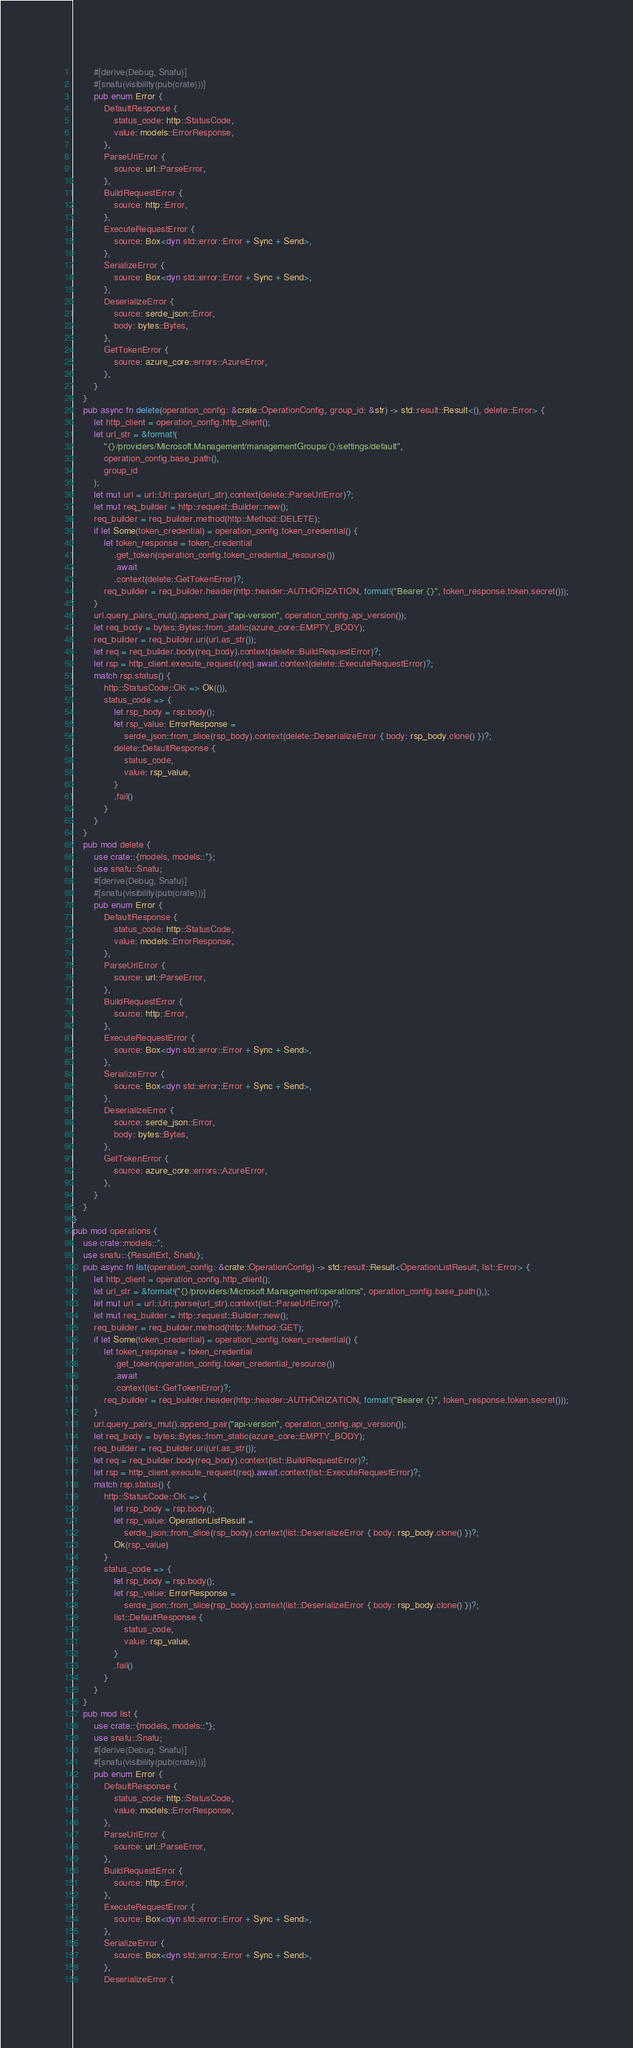<code> <loc_0><loc_0><loc_500><loc_500><_Rust_>        #[derive(Debug, Snafu)]
        #[snafu(visibility(pub(crate)))]
        pub enum Error {
            DefaultResponse {
                status_code: http::StatusCode,
                value: models::ErrorResponse,
            },
            ParseUrlError {
                source: url::ParseError,
            },
            BuildRequestError {
                source: http::Error,
            },
            ExecuteRequestError {
                source: Box<dyn std::error::Error + Sync + Send>,
            },
            SerializeError {
                source: Box<dyn std::error::Error + Sync + Send>,
            },
            DeserializeError {
                source: serde_json::Error,
                body: bytes::Bytes,
            },
            GetTokenError {
                source: azure_core::errors::AzureError,
            },
        }
    }
    pub async fn delete(operation_config: &crate::OperationConfig, group_id: &str) -> std::result::Result<(), delete::Error> {
        let http_client = operation_config.http_client();
        let url_str = &format!(
            "{}/providers/Microsoft.Management/managementGroups/{}/settings/default",
            operation_config.base_path(),
            group_id
        );
        let mut url = url::Url::parse(url_str).context(delete::ParseUrlError)?;
        let mut req_builder = http::request::Builder::new();
        req_builder = req_builder.method(http::Method::DELETE);
        if let Some(token_credential) = operation_config.token_credential() {
            let token_response = token_credential
                .get_token(operation_config.token_credential_resource())
                .await
                .context(delete::GetTokenError)?;
            req_builder = req_builder.header(http::header::AUTHORIZATION, format!("Bearer {}", token_response.token.secret()));
        }
        url.query_pairs_mut().append_pair("api-version", operation_config.api_version());
        let req_body = bytes::Bytes::from_static(azure_core::EMPTY_BODY);
        req_builder = req_builder.uri(url.as_str());
        let req = req_builder.body(req_body).context(delete::BuildRequestError)?;
        let rsp = http_client.execute_request(req).await.context(delete::ExecuteRequestError)?;
        match rsp.status() {
            http::StatusCode::OK => Ok(()),
            status_code => {
                let rsp_body = rsp.body();
                let rsp_value: ErrorResponse =
                    serde_json::from_slice(rsp_body).context(delete::DeserializeError { body: rsp_body.clone() })?;
                delete::DefaultResponse {
                    status_code,
                    value: rsp_value,
                }
                .fail()
            }
        }
    }
    pub mod delete {
        use crate::{models, models::*};
        use snafu::Snafu;
        #[derive(Debug, Snafu)]
        #[snafu(visibility(pub(crate)))]
        pub enum Error {
            DefaultResponse {
                status_code: http::StatusCode,
                value: models::ErrorResponse,
            },
            ParseUrlError {
                source: url::ParseError,
            },
            BuildRequestError {
                source: http::Error,
            },
            ExecuteRequestError {
                source: Box<dyn std::error::Error + Sync + Send>,
            },
            SerializeError {
                source: Box<dyn std::error::Error + Sync + Send>,
            },
            DeserializeError {
                source: serde_json::Error,
                body: bytes::Bytes,
            },
            GetTokenError {
                source: azure_core::errors::AzureError,
            },
        }
    }
}
pub mod operations {
    use crate::models::*;
    use snafu::{ResultExt, Snafu};
    pub async fn list(operation_config: &crate::OperationConfig) -> std::result::Result<OperationListResult, list::Error> {
        let http_client = operation_config.http_client();
        let url_str = &format!("{}/providers/Microsoft.Management/operations", operation_config.base_path(),);
        let mut url = url::Url::parse(url_str).context(list::ParseUrlError)?;
        let mut req_builder = http::request::Builder::new();
        req_builder = req_builder.method(http::Method::GET);
        if let Some(token_credential) = operation_config.token_credential() {
            let token_response = token_credential
                .get_token(operation_config.token_credential_resource())
                .await
                .context(list::GetTokenError)?;
            req_builder = req_builder.header(http::header::AUTHORIZATION, format!("Bearer {}", token_response.token.secret()));
        }
        url.query_pairs_mut().append_pair("api-version", operation_config.api_version());
        let req_body = bytes::Bytes::from_static(azure_core::EMPTY_BODY);
        req_builder = req_builder.uri(url.as_str());
        let req = req_builder.body(req_body).context(list::BuildRequestError)?;
        let rsp = http_client.execute_request(req).await.context(list::ExecuteRequestError)?;
        match rsp.status() {
            http::StatusCode::OK => {
                let rsp_body = rsp.body();
                let rsp_value: OperationListResult =
                    serde_json::from_slice(rsp_body).context(list::DeserializeError { body: rsp_body.clone() })?;
                Ok(rsp_value)
            }
            status_code => {
                let rsp_body = rsp.body();
                let rsp_value: ErrorResponse =
                    serde_json::from_slice(rsp_body).context(list::DeserializeError { body: rsp_body.clone() })?;
                list::DefaultResponse {
                    status_code,
                    value: rsp_value,
                }
                .fail()
            }
        }
    }
    pub mod list {
        use crate::{models, models::*};
        use snafu::Snafu;
        #[derive(Debug, Snafu)]
        #[snafu(visibility(pub(crate)))]
        pub enum Error {
            DefaultResponse {
                status_code: http::StatusCode,
                value: models::ErrorResponse,
            },
            ParseUrlError {
                source: url::ParseError,
            },
            BuildRequestError {
                source: http::Error,
            },
            ExecuteRequestError {
                source: Box<dyn std::error::Error + Sync + Send>,
            },
            SerializeError {
                source: Box<dyn std::error::Error + Sync + Send>,
            },
            DeserializeError {</code> 